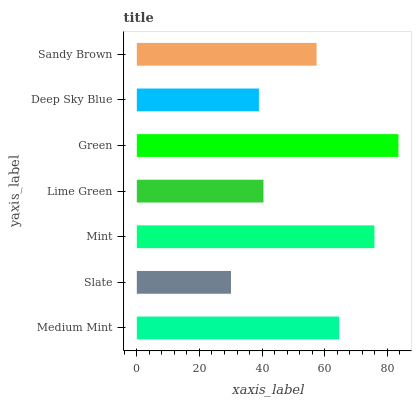Is Slate the minimum?
Answer yes or no. Yes. Is Green the maximum?
Answer yes or no. Yes. Is Mint the minimum?
Answer yes or no. No. Is Mint the maximum?
Answer yes or no. No. Is Mint greater than Slate?
Answer yes or no. Yes. Is Slate less than Mint?
Answer yes or no. Yes. Is Slate greater than Mint?
Answer yes or no. No. Is Mint less than Slate?
Answer yes or no. No. Is Sandy Brown the high median?
Answer yes or no. Yes. Is Sandy Brown the low median?
Answer yes or no. Yes. Is Lime Green the high median?
Answer yes or no. No. Is Green the low median?
Answer yes or no. No. 